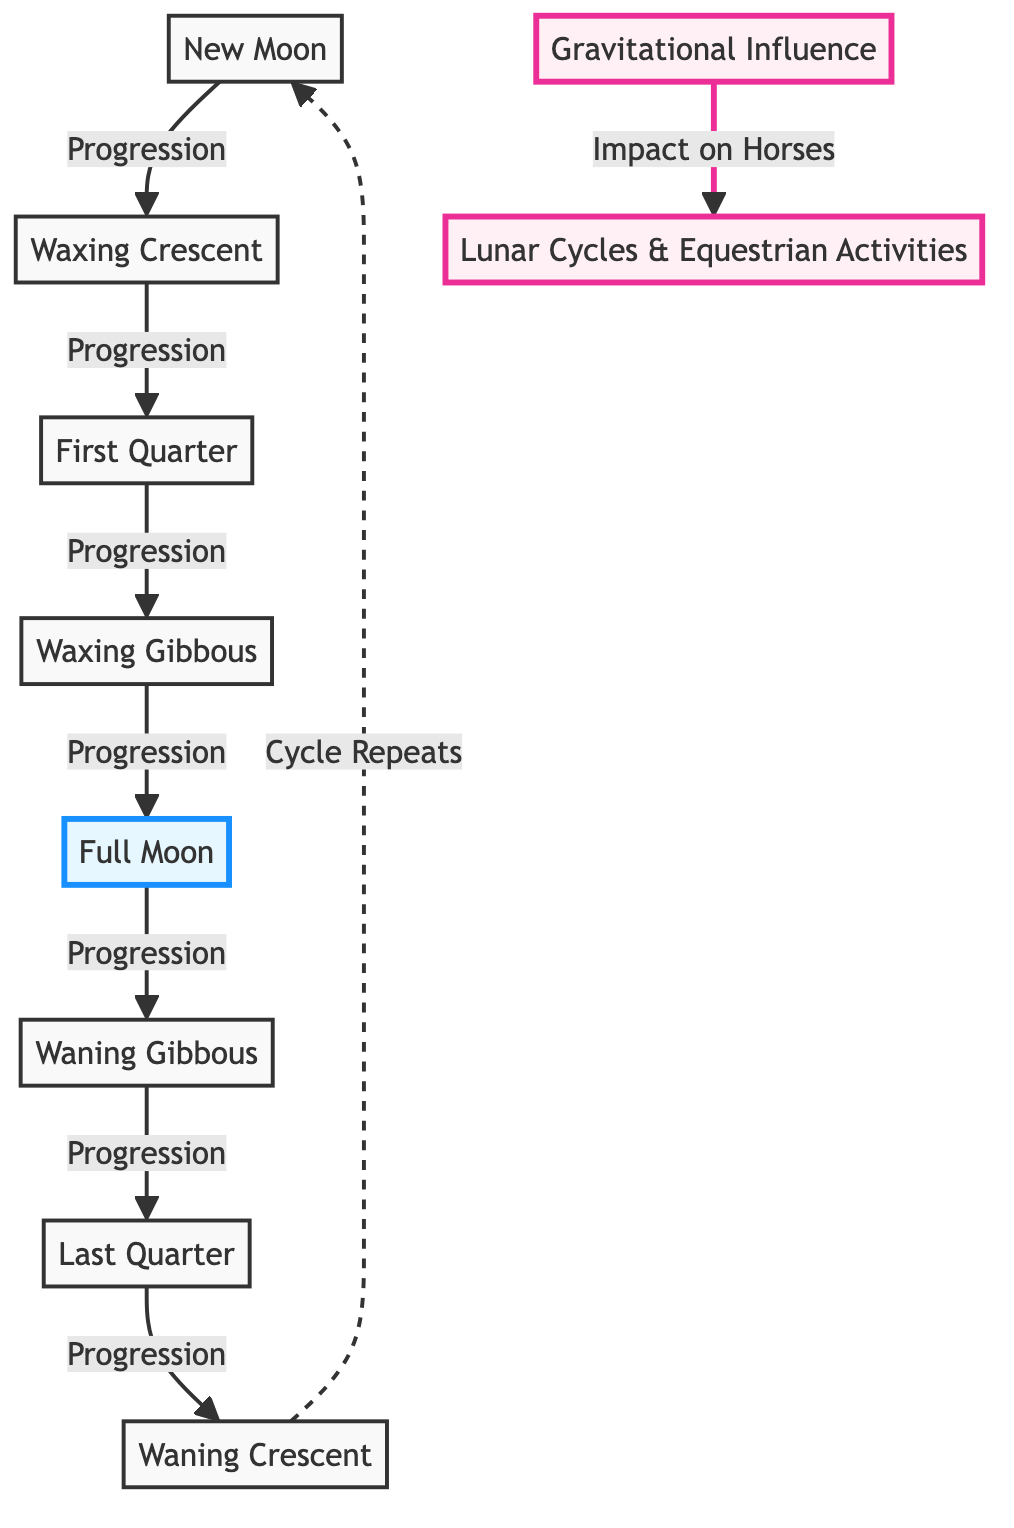What are the eight phases of the Moon depicted in the diagram? The diagram lists the phases of the Moon as follows: New Moon, Waxing Crescent, First Quarter, Waxing Gibbous, Full Moon, Waning Gibbous, Last Quarter, and Waning Crescent. This describes the flow from one phase to the next.
Answer: New Moon, Waxing Crescent, First Quarter, Waxing Gibbous, Full Moon, Waning Gibbous, Last Quarter, Waning Crescent Which phase of the Moon is highlighted in the diagram? The diagram uses a different color to emphasize the Full Moon as it has a special significance in lunar cycles and equestrian activities. The highlight indicates its importance visually.
Answer: Full Moon What progression follows the Waxing Crescent phase? The arrows in the diagram connect Waxing Crescent to the next phase, which is the First Quarter. This shows the order of progression between the Moon phases.
Answer: First Quarter How many distinct phases of the Moon are illustrated in the diagram? By counting the eight nodes labeled as phases of the Moon in the diagram, we find there are a total of eight distinct phases represented.
Answer: 8 What connection does the Full Moon phase have with equestrian activities? The diagram indicates an impact line connecting "Gravitational Influence" to "Lunar Cycles & Equestrian Activities," suggesting that the gravitational effects during certain lunar phases, especially the Full Moon, influence equestrian performance.
Answer: Impact on Horses What element signifies the repeat cycle of the Moon phases? The dashed line leading back from the Waning Crescent to the New Moon denotes the cycle's repetition, indicating that after completing the eight phases, the cycle starts over again. This visual representation illustrates the continuous nature of lunar phases.
Answer: Cycle Repeats Which phase occurs immediately after the Full Moon? In the flow progression of the diagram, the phase that directly follows Full Moon is the Waning Gibbous, showing the order of phases and how they transition into one another.
Answer: Waning Gibbous What effect does the gravitational influence have as shown in the diagram? The influence is described within nodes and arrows connecting to equestrian activities, indicating that lunar gravitational effects can impact horse behavior or performance during certain phases of the Moon, particularly during the Full Moon.
Answer: Lunar Cycles & Equestrian Activities 